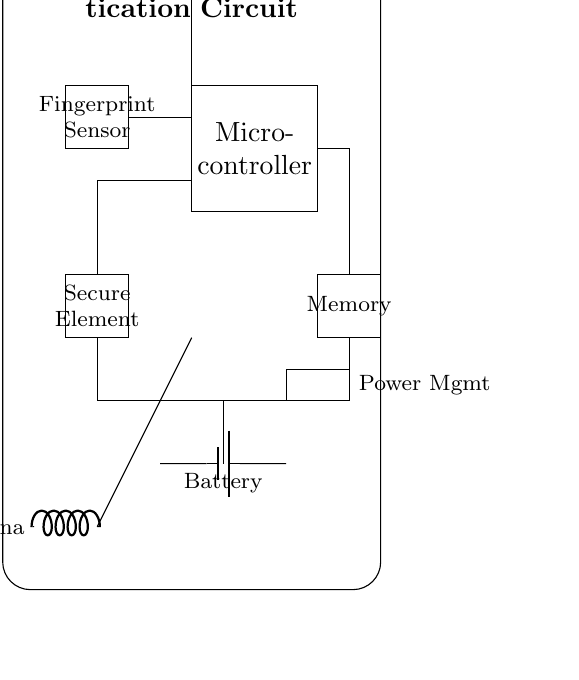What component is used for biometric authentication? The component used for biometric authentication is the fingerprint sensor, as indicated in the circuit diagram.
Answer: Fingerprint Sensor What powers this circuit? The power source for the circuit is the battery, which is represented as a power supply component at the bottom of the diagram.
Answer: Battery How many main components are shown in the circuit? There are five main components in the circuit: the fingerprint sensor, micro-controller, secure element, memory, and power management.
Answer: Five What is the purpose of the secure element in this circuit? The secure element safeguards sensitive data, such as biometric information, helping to enhance the security of the authentication process.
Answer: Data security What is the role of the micro-controller in the circuit? The micro-controller processes the data received from the fingerprint sensor and manages the communication with the secure element and memory.
Answer: Data processing Which component is connected to the antenna? The secure element is connected to the antenna, which is responsible for communication purposes, as seen in the connection line.
Answer: Secure Element How does the fingerprint sensor communicate with the micro-controller? The fingerprint sensor communicates with the micro-controller through a direct connection (represented by a line in the circuit), allowing data transfer for processing.
Answer: Direct connection 